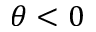Convert formula to latex. <formula><loc_0><loc_0><loc_500><loc_500>\theta < 0</formula> 